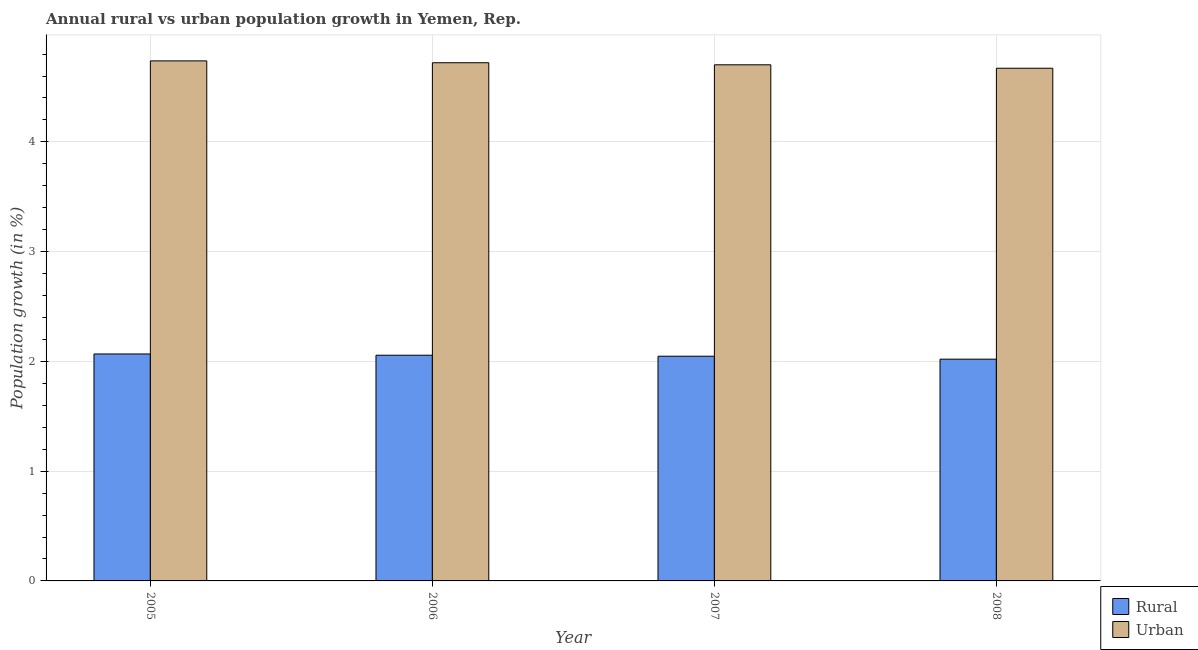How many groups of bars are there?
Make the answer very short. 4. Are the number of bars per tick equal to the number of legend labels?
Your answer should be very brief. Yes. Are the number of bars on each tick of the X-axis equal?
Keep it short and to the point. Yes. How many bars are there on the 1st tick from the left?
Your answer should be compact. 2. How many bars are there on the 4th tick from the right?
Offer a terse response. 2. In how many cases, is the number of bars for a given year not equal to the number of legend labels?
Ensure brevity in your answer.  0. What is the urban population growth in 2007?
Provide a succinct answer. 4.7. Across all years, what is the maximum urban population growth?
Ensure brevity in your answer.  4.74. Across all years, what is the minimum urban population growth?
Keep it short and to the point. 4.67. What is the total rural population growth in the graph?
Keep it short and to the point. 8.19. What is the difference between the rural population growth in 2006 and that in 2007?
Your answer should be compact. 0.01. What is the difference between the urban population growth in 2008 and the rural population growth in 2006?
Ensure brevity in your answer.  -0.05. What is the average rural population growth per year?
Give a very brief answer. 2.05. What is the ratio of the rural population growth in 2005 to that in 2008?
Make the answer very short. 1.02. Is the rural population growth in 2005 less than that in 2007?
Offer a very short reply. No. Is the difference between the rural population growth in 2005 and 2006 greater than the difference between the urban population growth in 2005 and 2006?
Ensure brevity in your answer.  No. What is the difference between the highest and the second highest urban population growth?
Make the answer very short. 0.02. What is the difference between the highest and the lowest urban population growth?
Make the answer very short. 0.07. Is the sum of the rural population growth in 2005 and 2007 greater than the maximum urban population growth across all years?
Your response must be concise. Yes. What does the 1st bar from the left in 2008 represents?
Provide a short and direct response. Rural. What does the 2nd bar from the right in 2006 represents?
Your answer should be compact. Rural. Are all the bars in the graph horizontal?
Make the answer very short. No. How many years are there in the graph?
Give a very brief answer. 4. Does the graph contain any zero values?
Make the answer very short. No. How are the legend labels stacked?
Your answer should be compact. Vertical. What is the title of the graph?
Give a very brief answer. Annual rural vs urban population growth in Yemen, Rep. What is the label or title of the X-axis?
Your answer should be very brief. Year. What is the label or title of the Y-axis?
Provide a short and direct response. Population growth (in %). What is the Population growth (in %) of Rural in 2005?
Offer a very short reply. 2.07. What is the Population growth (in %) of Urban  in 2005?
Offer a terse response. 4.74. What is the Population growth (in %) in Rural in 2006?
Your answer should be compact. 2.06. What is the Population growth (in %) in Urban  in 2006?
Ensure brevity in your answer.  4.72. What is the Population growth (in %) of Rural in 2007?
Ensure brevity in your answer.  2.05. What is the Population growth (in %) in Urban  in 2007?
Provide a succinct answer. 4.7. What is the Population growth (in %) of Rural in 2008?
Provide a succinct answer. 2.02. What is the Population growth (in %) of Urban  in 2008?
Keep it short and to the point. 4.67. Across all years, what is the maximum Population growth (in %) in Rural?
Provide a short and direct response. 2.07. Across all years, what is the maximum Population growth (in %) in Urban ?
Give a very brief answer. 4.74. Across all years, what is the minimum Population growth (in %) in Rural?
Offer a terse response. 2.02. Across all years, what is the minimum Population growth (in %) of Urban ?
Your response must be concise. 4.67. What is the total Population growth (in %) in Rural in the graph?
Ensure brevity in your answer.  8.19. What is the total Population growth (in %) of Urban  in the graph?
Provide a short and direct response. 18.83. What is the difference between the Population growth (in %) of Rural in 2005 and that in 2006?
Provide a short and direct response. 0.01. What is the difference between the Population growth (in %) of Urban  in 2005 and that in 2006?
Give a very brief answer. 0.02. What is the difference between the Population growth (in %) in Rural in 2005 and that in 2007?
Ensure brevity in your answer.  0.02. What is the difference between the Population growth (in %) of Urban  in 2005 and that in 2007?
Keep it short and to the point. 0.04. What is the difference between the Population growth (in %) in Rural in 2005 and that in 2008?
Your answer should be compact. 0.05. What is the difference between the Population growth (in %) in Urban  in 2005 and that in 2008?
Your answer should be very brief. 0.07. What is the difference between the Population growth (in %) of Rural in 2006 and that in 2007?
Your answer should be very brief. 0.01. What is the difference between the Population growth (in %) of Urban  in 2006 and that in 2007?
Provide a short and direct response. 0.02. What is the difference between the Population growth (in %) of Rural in 2006 and that in 2008?
Offer a terse response. 0.04. What is the difference between the Population growth (in %) in Urban  in 2006 and that in 2008?
Provide a short and direct response. 0.05. What is the difference between the Population growth (in %) in Rural in 2007 and that in 2008?
Keep it short and to the point. 0.03. What is the difference between the Population growth (in %) of Urban  in 2007 and that in 2008?
Provide a succinct answer. 0.03. What is the difference between the Population growth (in %) of Rural in 2005 and the Population growth (in %) of Urban  in 2006?
Your answer should be compact. -2.65. What is the difference between the Population growth (in %) of Rural in 2005 and the Population growth (in %) of Urban  in 2007?
Your answer should be compact. -2.63. What is the difference between the Population growth (in %) of Rural in 2005 and the Population growth (in %) of Urban  in 2008?
Your answer should be compact. -2.6. What is the difference between the Population growth (in %) of Rural in 2006 and the Population growth (in %) of Urban  in 2007?
Your response must be concise. -2.65. What is the difference between the Population growth (in %) in Rural in 2006 and the Population growth (in %) in Urban  in 2008?
Provide a succinct answer. -2.61. What is the difference between the Population growth (in %) in Rural in 2007 and the Population growth (in %) in Urban  in 2008?
Your response must be concise. -2.62. What is the average Population growth (in %) in Rural per year?
Provide a short and direct response. 2.05. What is the average Population growth (in %) in Urban  per year?
Provide a succinct answer. 4.71. In the year 2005, what is the difference between the Population growth (in %) in Rural and Population growth (in %) in Urban ?
Make the answer very short. -2.67. In the year 2006, what is the difference between the Population growth (in %) in Rural and Population growth (in %) in Urban ?
Your response must be concise. -2.66. In the year 2007, what is the difference between the Population growth (in %) of Rural and Population growth (in %) of Urban ?
Offer a very short reply. -2.65. In the year 2008, what is the difference between the Population growth (in %) of Rural and Population growth (in %) of Urban ?
Provide a succinct answer. -2.65. What is the ratio of the Population growth (in %) in Rural in 2005 to that in 2006?
Offer a terse response. 1.01. What is the ratio of the Population growth (in %) of Urban  in 2005 to that in 2006?
Offer a terse response. 1. What is the ratio of the Population growth (in %) in Rural in 2005 to that in 2007?
Your answer should be compact. 1.01. What is the ratio of the Population growth (in %) in Urban  in 2005 to that in 2007?
Your answer should be very brief. 1.01. What is the ratio of the Population growth (in %) in Rural in 2005 to that in 2008?
Your response must be concise. 1.02. What is the ratio of the Population growth (in %) in Urban  in 2005 to that in 2008?
Provide a short and direct response. 1.01. What is the ratio of the Population growth (in %) in Rural in 2006 to that in 2007?
Your answer should be compact. 1. What is the ratio of the Population growth (in %) in Rural in 2006 to that in 2008?
Your answer should be compact. 1.02. What is the ratio of the Population growth (in %) in Urban  in 2006 to that in 2008?
Offer a very short reply. 1.01. What is the ratio of the Population growth (in %) in Rural in 2007 to that in 2008?
Give a very brief answer. 1.01. What is the ratio of the Population growth (in %) in Urban  in 2007 to that in 2008?
Ensure brevity in your answer.  1.01. What is the difference between the highest and the second highest Population growth (in %) of Rural?
Provide a short and direct response. 0.01. What is the difference between the highest and the second highest Population growth (in %) of Urban ?
Your response must be concise. 0.02. What is the difference between the highest and the lowest Population growth (in %) in Rural?
Offer a very short reply. 0.05. What is the difference between the highest and the lowest Population growth (in %) of Urban ?
Your response must be concise. 0.07. 